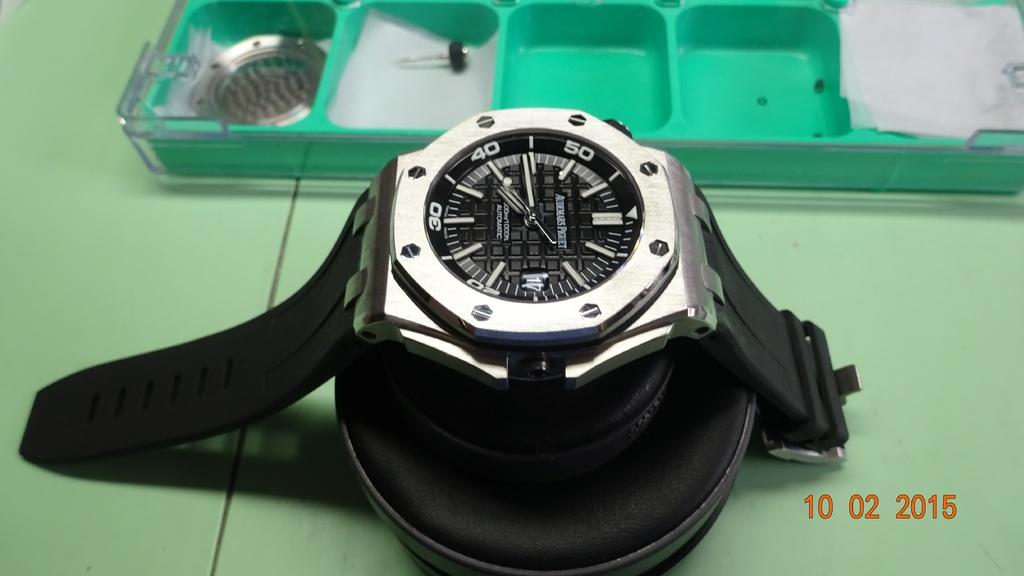Provide a one-sentence caption for the provided image. A watch is displayed on a green table and shows a time of 7:44. 